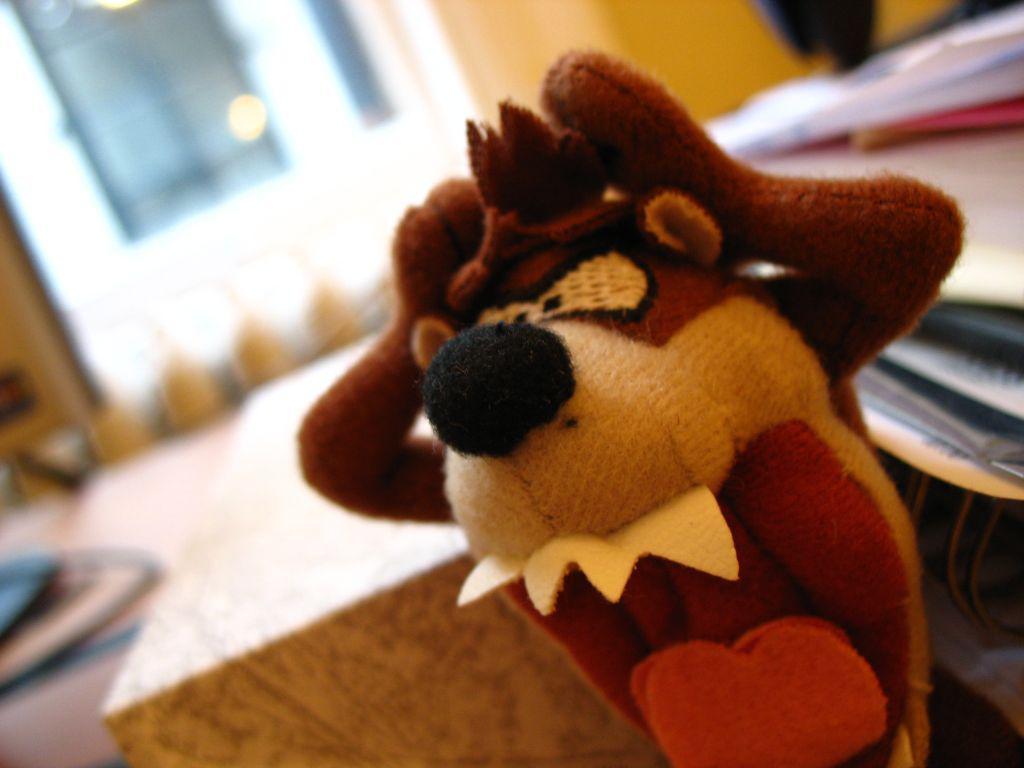Can you describe this image briefly? In this picture I can see a doll in the middle, in the background there is the blur. 